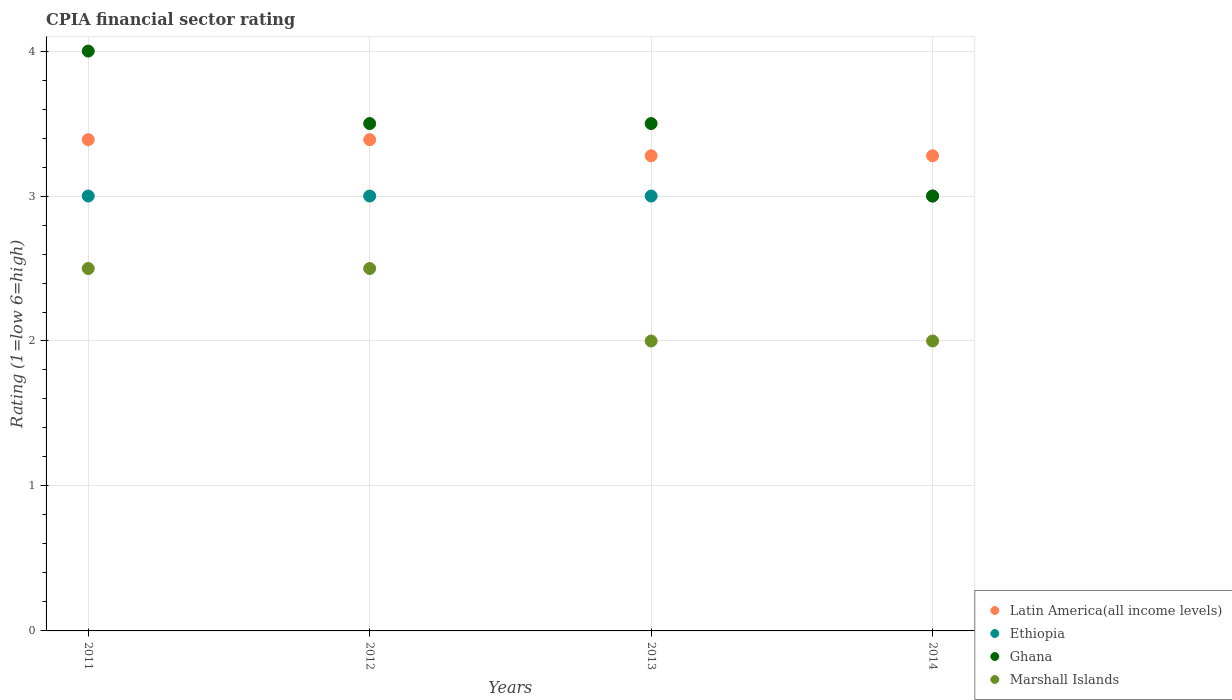What is the CPIA rating in Latin America(all income levels) in 2012?
Offer a very short reply. 3.39. Across all years, what is the minimum CPIA rating in Ethiopia?
Provide a succinct answer. 3. In which year was the CPIA rating in Marshall Islands maximum?
Offer a terse response. 2011. In which year was the CPIA rating in Latin America(all income levels) minimum?
Your answer should be very brief. 2013. What is the total CPIA rating in Marshall Islands in the graph?
Your answer should be very brief. 9. What is the difference between the CPIA rating in Ghana in 2012 and that in 2013?
Keep it short and to the point. 0. What is the difference between the CPIA rating in Marshall Islands in 2013 and the CPIA rating in Ghana in 2012?
Make the answer very short. -1.5. What is the average CPIA rating in Latin America(all income levels) per year?
Your answer should be very brief. 3.33. In the year 2013, what is the difference between the CPIA rating in Ghana and CPIA rating in Latin America(all income levels)?
Keep it short and to the point. 0.22. In how many years, is the CPIA rating in Ethiopia greater than 3.6?
Your response must be concise. 0. Is the CPIA rating in Latin America(all income levels) in 2011 less than that in 2014?
Give a very brief answer. No. Is the difference between the CPIA rating in Ghana in 2011 and 2013 greater than the difference between the CPIA rating in Latin America(all income levels) in 2011 and 2013?
Your answer should be very brief. Yes. What is the difference between the highest and the second highest CPIA rating in Latin America(all income levels)?
Your answer should be compact. 0. What is the difference between the highest and the lowest CPIA rating in Marshall Islands?
Offer a very short reply. 0.5. Is the sum of the CPIA rating in Ghana in 2011 and 2014 greater than the maximum CPIA rating in Ethiopia across all years?
Keep it short and to the point. Yes. Does the CPIA rating in Latin America(all income levels) monotonically increase over the years?
Make the answer very short. No. Is the CPIA rating in Marshall Islands strictly less than the CPIA rating in Ethiopia over the years?
Provide a short and direct response. Yes. How many years are there in the graph?
Make the answer very short. 4. What is the difference between two consecutive major ticks on the Y-axis?
Your answer should be very brief. 1. Does the graph contain any zero values?
Your answer should be compact. No. How many legend labels are there?
Keep it short and to the point. 4. How are the legend labels stacked?
Your response must be concise. Vertical. What is the title of the graph?
Your answer should be compact. CPIA financial sector rating. What is the label or title of the X-axis?
Give a very brief answer. Years. What is the Rating (1=low 6=high) of Latin America(all income levels) in 2011?
Ensure brevity in your answer.  3.39. What is the Rating (1=low 6=high) in Ethiopia in 2011?
Your answer should be compact. 3. What is the Rating (1=low 6=high) of Ghana in 2011?
Keep it short and to the point. 4. What is the Rating (1=low 6=high) in Marshall Islands in 2011?
Provide a short and direct response. 2.5. What is the Rating (1=low 6=high) in Latin America(all income levels) in 2012?
Provide a short and direct response. 3.39. What is the Rating (1=low 6=high) in Ethiopia in 2012?
Provide a succinct answer. 3. What is the Rating (1=low 6=high) of Latin America(all income levels) in 2013?
Make the answer very short. 3.28. What is the Rating (1=low 6=high) of Ghana in 2013?
Make the answer very short. 3.5. What is the Rating (1=low 6=high) in Latin America(all income levels) in 2014?
Ensure brevity in your answer.  3.28. What is the Rating (1=low 6=high) of Ethiopia in 2014?
Offer a very short reply. 3. What is the Rating (1=low 6=high) of Ghana in 2014?
Your answer should be very brief. 3. What is the Rating (1=low 6=high) of Marshall Islands in 2014?
Your answer should be compact. 2. Across all years, what is the maximum Rating (1=low 6=high) of Latin America(all income levels)?
Ensure brevity in your answer.  3.39. Across all years, what is the maximum Rating (1=low 6=high) in Ghana?
Give a very brief answer. 4. Across all years, what is the minimum Rating (1=low 6=high) of Latin America(all income levels)?
Make the answer very short. 3.28. Across all years, what is the minimum Rating (1=low 6=high) of Ghana?
Provide a succinct answer. 3. What is the total Rating (1=low 6=high) of Latin America(all income levels) in the graph?
Provide a succinct answer. 13.33. What is the total Rating (1=low 6=high) of Ethiopia in the graph?
Offer a terse response. 12. What is the total Rating (1=low 6=high) of Marshall Islands in the graph?
Offer a terse response. 9. What is the difference between the Rating (1=low 6=high) in Ghana in 2011 and that in 2012?
Keep it short and to the point. 0.5. What is the difference between the Rating (1=low 6=high) in Marshall Islands in 2011 and that in 2012?
Your response must be concise. 0. What is the difference between the Rating (1=low 6=high) of Latin America(all income levels) in 2011 and that in 2013?
Your answer should be very brief. 0.11. What is the difference between the Rating (1=low 6=high) in Ethiopia in 2011 and that in 2013?
Ensure brevity in your answer.  0. What is the difference between the Rating (1=low 6=high) of Marshall Islands in 2011 and that in 2013?
Give a very brief answer. 0.5. What is the difference between the Rating (1=low 6=high) in Latin America(all income levels) in 2011 and that in 2014?
Your answer should be very brief. 0.11. What is the difference between the Rating (1=low 6=high) of Latin America(all income levels) in 2012 and that in 2013?
Your response must be concise. 0.11. What is the difference between the Rating (1=low 6=high) of Ethiopia in 2012 and that in 2013?
Make the answer very short. 0. What is the difference between the Rating (1=low 6=high) of Ghana in 2012 and that in 2013?
Make the answer very short. 0. What is the difference between the Rating (1=low 6=high) in Marshall Islands in 2012 and that in 2013?
Keep it short and to the point. 0.5. What is the difference between the Rating (1=low 6=high) in Latin America(all income levels) in 2012 and that in 2014?
Provide a succinct answer. 0.11. What is the difference between the Rating (1=low 6=high) of Marshall Islands in 2012 and that in 2014?
Ensure brevity in your answer.  0.5. What is the difference between the Rating (1=low 6=high) of Ethiopia in 2013 and that in 2014?
Keep it short and to the point. 0. What is the difference between the Rating (1=low 6=high) of Ghana in 2013 and that in 2014?
Your answer should be very brief. 0.5. What is the difference between the Rating (1=low 6=high) in Marshall Islands in 2013 and that in 2014?
Ensure brevity in your answer.  0. What is the difference between the Rating (1=low 6=high) of Latin America(all income levels) in 2011 and the Rating (1=low 6=high) of Ethiopia in 2012?
Give a very brief answer. 0.39. What is the difference between the Rating (1=low 6=high) of Latin America(all income levels) in 2011 and the Rating (1=low 6=high) of Ghana in 2012?
Your answer should be compact. -0.11. What is the difference between the Rating (1=low 6=high) in Ethiopia in 2011 and the Rating (1=low 6=high) in Marshall Islands in 2012?
Offer a terse response. 0.5. What is the difference between the Rating (1=low 6=high) of Ghana in 2011 and the Rating (1=low 6=high) of Marshall Islands in 2012?
Your answer should be very brief. 1.5. What is the difference between the Rating (1=low 6=high) of Latin America(all income levels) in 2011 and the Rating (1=low 6=high) of Ethiopia in 2013?
Keep it short and to the point. 0.39. What is the difference between the Rating (1=low 6=high) in Latin America(all income levels) in 2011 and the Rating (1=low 6=high) in Ghana in 2013?
Keep it short and to the point. -0.11. What is the difference between the Rating (1=low 6=high) in Latin America(all income levels) in 2011 and the Rating (1=low 6=high) in Marshall Islands in 2013?
Provide a short and direct response. 1.39. What is the difference between the Rating (1=low 6=high) of Ethiopia in 2011 and the Rating (1=low 6=high) of Marshall Islands in 2013?
Keep it short and to the point. 1. What is the difference between the Rating (1=low 6=high) of Latin America(all income levels) in 2011 and the Rating (1=low 6=high) of Ethiopia in 2014?
Your response must be concise. 0.39. What is the difference between the Rating (1=low 6=high) in Latin America(all income levels) in 2011 and the Rating (1=low 6=high) in Ghana in 2014?
Provide a succinct answer. 0.39. What is the difference between the Rating (1=low 6=high) in Latin America(all income levels) in 2011 and the Rating (1=low 6=high) in Marshall Islands in 2014?
Make the answer very short. 1.39. What is the difference between the Rating (1=low 6=high) in Ethiopia in 2011 and the Rating (1=low 6=high) in Ghana in 2014?
Your answer should be compact. 0. What is the difference between the Rating (1=low 6=high) of Ethiopia in 2011 and the Rating (1=low 6=high) of Marshall Islands in 2014?
Provide a succinct answer. 1. What is the difference between the Rating (1=low 6=high) of Ghana in 2011 and the Rating (1=low 6=high) of Marshall Islands in 2014?
Your answer should be very brief. 2. What is the difference between the Rating (1=low 6=high) in Latin America(all income levels) in 2012 and the Rating (1=low 6=high) in Ethiopia in 2013?
Offer a very short reply. 0.39. What is the difference between the Rating (1=low 6=high) of Latin America(all income levels) in 2012 and the Rating (1=low 6=high) of Ghana in 2013?
Ensure brevity in your answer.  -0.11. What is the difference between the Rating (1=low 6=high) of Latin America(all income levels) in 2012 and the Rating (1=low 6=high) of Marshall Islands in 2013?
Offer a very short reply. 1.39. What is the difference between the Rating (1=low 6=high) of Latin America(all income levels) in 2012 and the Rating (1=low 6=high) of Ethiopia in 2014?
Your answer should be very brief. 0.39. What is the difference between the Rating (1=low 6=high) of Latin America(all income levels) in 2012 and the Rating (1=low 6=high) of Ghana in 2014?
Offer a terse response. 0.39. What is the difference between the Rating (1=low 6=high) in Latin America(all income levels) in 2012 and the Rating (1=low 6=high) in Marshall Islands in 2014?
Keep it short and to the point. 1.39. What is the difference between the Rating (1=low 6=high) in Ghana in 2012 and the Rating (1=low 6=high) in Marshall Islands in 2014?
Give a very brief answer. 1.5. What is the difference between the Rating (1=low 6=high) of Latin America(all income levels) in 2013 and the Rating (1=low 6=high) of Ethiopia in 2014?
Your answer should be compact. 0.28. What is the difference between the Rating (1=low 6=high) in Latin America(all income levels) in 2013 and the Rating (1=low 6=high) in Ghana in 2014?
Ensure brevity in your answer.  0.28. What is the difference between the Rating (1=low 6=high) of Latin America(all income levels) in 2013 and the Rating (1=low 6=high) of Marshall Islands in 2014?
Your answer should be very brief. 1.28. What is the difference between the Rating (1=low 6=high) in Ethiopia in 2013 and the Rating (1=low 6=high) in Ghana in 2014?
Provide a succinct answer. 0. What is the average Rating (1=low 6=high) of Ghana per year?
Provide a succinct answer. 3.5. What is the average Rating (1=low 6=high) in Marshall Islands per year?
Your answer should be very brief. 2.25. In the year 2011, what is the difference between the Rating (1=low 6=high) in Latin America(all income levels) and Rating (1=low 6=high) in Ethiopia?
Make the answer very short. 0.39. In the year 2011, what is the difference between the Rating (1=low 6=high) in Latin America(all income levels) and Rating (1=low 6=high) in Ghana?
Give a very brief answer. -0.61. In the year 2011, what is the difference between the Rating (1=low 6=high) of Latin America(all income levels) and Rating (1=low 6=high) of Marshall Islands?
Keep it short and to the point. 0.89. In the year 2011, what is the difference between the Rating (1=low 6=high) in Ethiopia and Rating (1=low 6=high) in Ghana?
Give a very brief answer. -1. In the year 2011, what is the difference between the Rating (1=low 6=high) of Ghana and Rating (1=low 6=high) of Marshall Islands?
Make the answer very short. 1.5. In the year 2012, what is the difference between the Rating (1=low 6=high) of Latin America(all income levels) and Rating (1=low 6=high) of Ethiopia?
Offer a very short reply. 0.39. In the year 2012, what is the difference between the Rating (1=low 6=high) in Latin America(all income levels) and Rating (1=low 6=high) in Ghana?
Give a very brief answer. -0.11. In the year 2012, what is the difference between the Rating (1=low 6=high) of Latin America(all income levels) and Rating (1=low 6=high) of Marshall Islands?
Provide a succinct answer. 0.89. In the year 2012, what is the difference between the Rating (1=low 6=high) of Ethiopia and Rating (1=low 6=high) of Ghana?
Your response must be concise. -0.5. In the year 2012, what is the difference between the Rating (1=low 6=high) in Ethiopia and Rating (1=low 6=high) in Marshall Islands?
Offer a terse response. 0.5. In the year 2013, what is the difference between the Rating (1=low 6=high) in Latin America(all income levels) and Rating (1=low 6=high) in Ethiopia?
Provide a short and direct response. 0.28. In the year 2013, what is the difference between the Rating (1=low 6=high) in Latin America(all income levels) and Rating (1=low 6=high) in Ghana?
Keep it short and to the point. -0.22. In the year 2013, what is the difference between the Rating (1=low 6=high) in Latin America(all income levels) and Rating (1=low 6=high) in Marshall Islands?
Ensure brevity in your answer.  1.28. In the year 2013, what is the difference between the Rating (1=low 6=high) of Ethiopia and Rating (1=low 6=high) of Ghana?
Give a very brief answer. -0.5. In the year 2013, what is the difference between the Rating (1=low 6=high) in Ghana and Rating (1=low 6=high) in Marshall Islands?
Offer a very short reply. 1.5. In the year 2014, what is the difference between the Rating (1=low 6=high) of Latin America(all income levels) and Rating (1=low 6=high) of Ethiopia?
Make the answer very short. 0.28. In the year 2014, what is the difference between the Rating (1=low 6=high) of Latin America(all income levels) and Rating (1=low 6=high) of Ghana?
Your answer should be compact. 0.28. In the year 2014, what is the difference between the Rating (1=low 6=high) in Latin America(all income levels) and Rating (1=low 6=high) in Marshall Islands?
Offer a very short reply. 1.28. In the year 2014, what is the difference between the Rating (1=low 6=high) in Ghana and Rating (1=low 6=high) in Marshall Islands?
Provide a short and direct response. 1. What is the ratio of the Rating (1=low 6=high) in Latin America(all income levels) in 2011 to that in 2012?
Your answer should be compact. 1. What is the ratio of the Rating (1=low 6=high) of Ethiopia in 2011 to that in 2012?
Ensure brevity in your answer.  1. What is the ratio of the Rating (1=low 6=high) in Marshall Islands in 2011 to that in 2012?
Ensure brevity in your answer.  1. What is the ratio of the Rating (1=low 6=high) in Latin America(all income levels) in 2011 to that in 2013?
Provide a succinct answer. 1.03. What is the ratio of the Rating (1=low 6=high) in Latin America(all income levels) in 2011 to that in 2014?
Your response must be concise. 1.03. What is the ratio of the Rating (1=low 6=high) of Ghana in 2011 to that in 2014?
Provide a short and direct response. 1.33. What is the ratio of the Rating (1=low 6=high) of Latin America(all income levels) in 2012 to that in 2013?
Keep it short and to the point. 1.03. What is the ratio of the Rating (1=low 6=high) in Ethiopia in 2012 to that in 2013?
Your answer should be compact. 1. What is the ratio of the Rating (1=low 6=high) in Latin America(all income levels) in 2012 to that in 2014?
Provide a short and direct response. 1.03. What is the ratio of the Rating (1=low 6=high) of Ghana in 2012 to that in 2014?
Your answer should be compact. 1.17. What is the ratio of the Rating (1=low 6=high) in Ghana in 2013 to that in 2014?
Your response must be concise. 1.17. What is the difference between the highest and the second highest Rating (1=low 6=high) in Marshall Islands?
Keep it short and to the point. 0. What is the difference between the highest and the lowest Rating (1=low 6=high) in Ethiopia?
Provide a short and direct response. 0. What is the difference between the highest and the lowest Rating (1=low 6=high) of Ghana?
Provide a short and direct response. 1. What is the difference between the highest and the lowest Rating (1=low 6=high) in Marshall Islands?
Offer a very short reply. 0.5. 